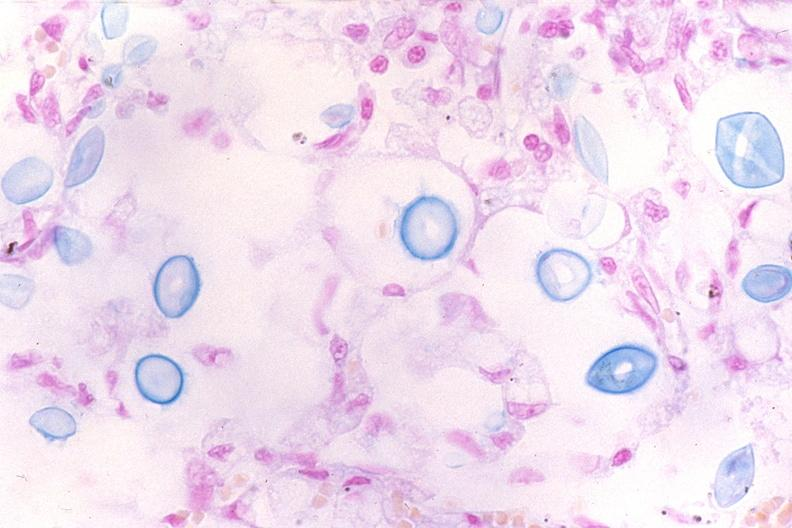does this image show lung, cryptococcal pneumonia?
Answer the question using a single word or phrase. Yes 